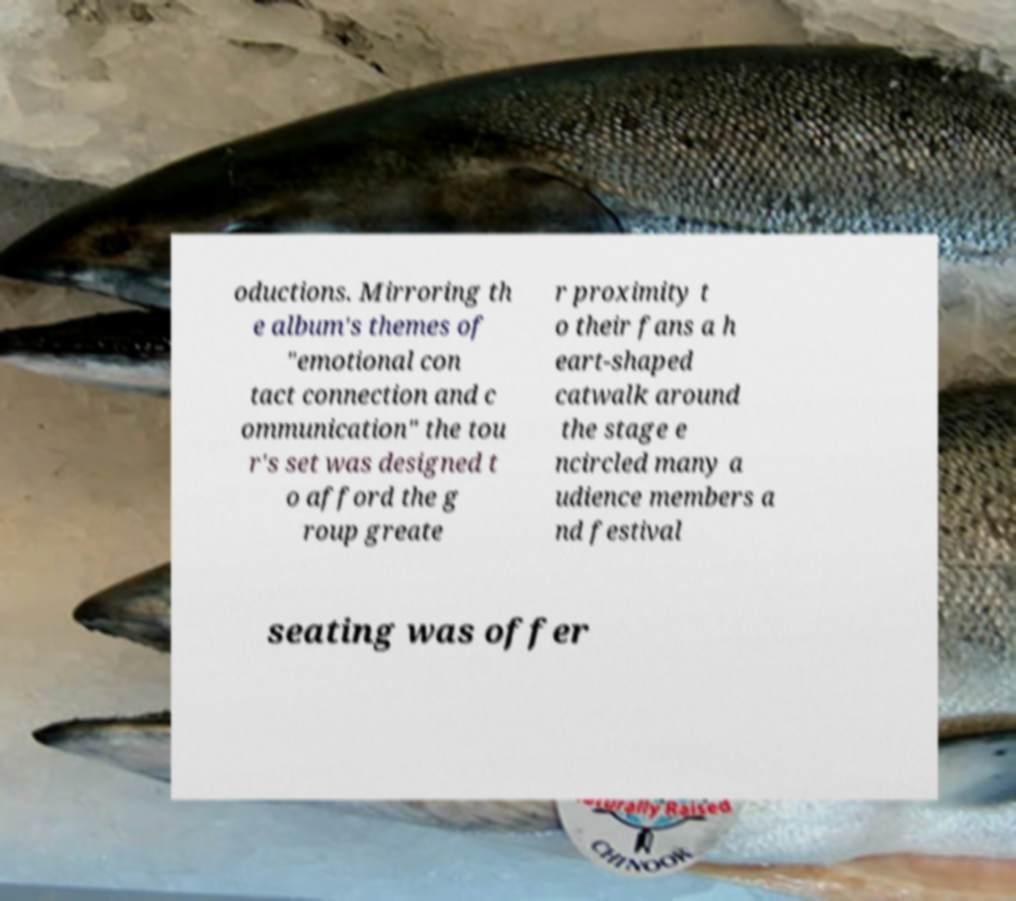Can you accurately transcribe the text from the provided image for me? oductions. Mirroring th e album's themes of "emotional con tact connection and c ommunication" the tou r's set was designed t o afford the g roup greate r proximity t o their fans a h eart-shaped catwalk around the stage e ncircled many a udience members a nd festival seating was offer 